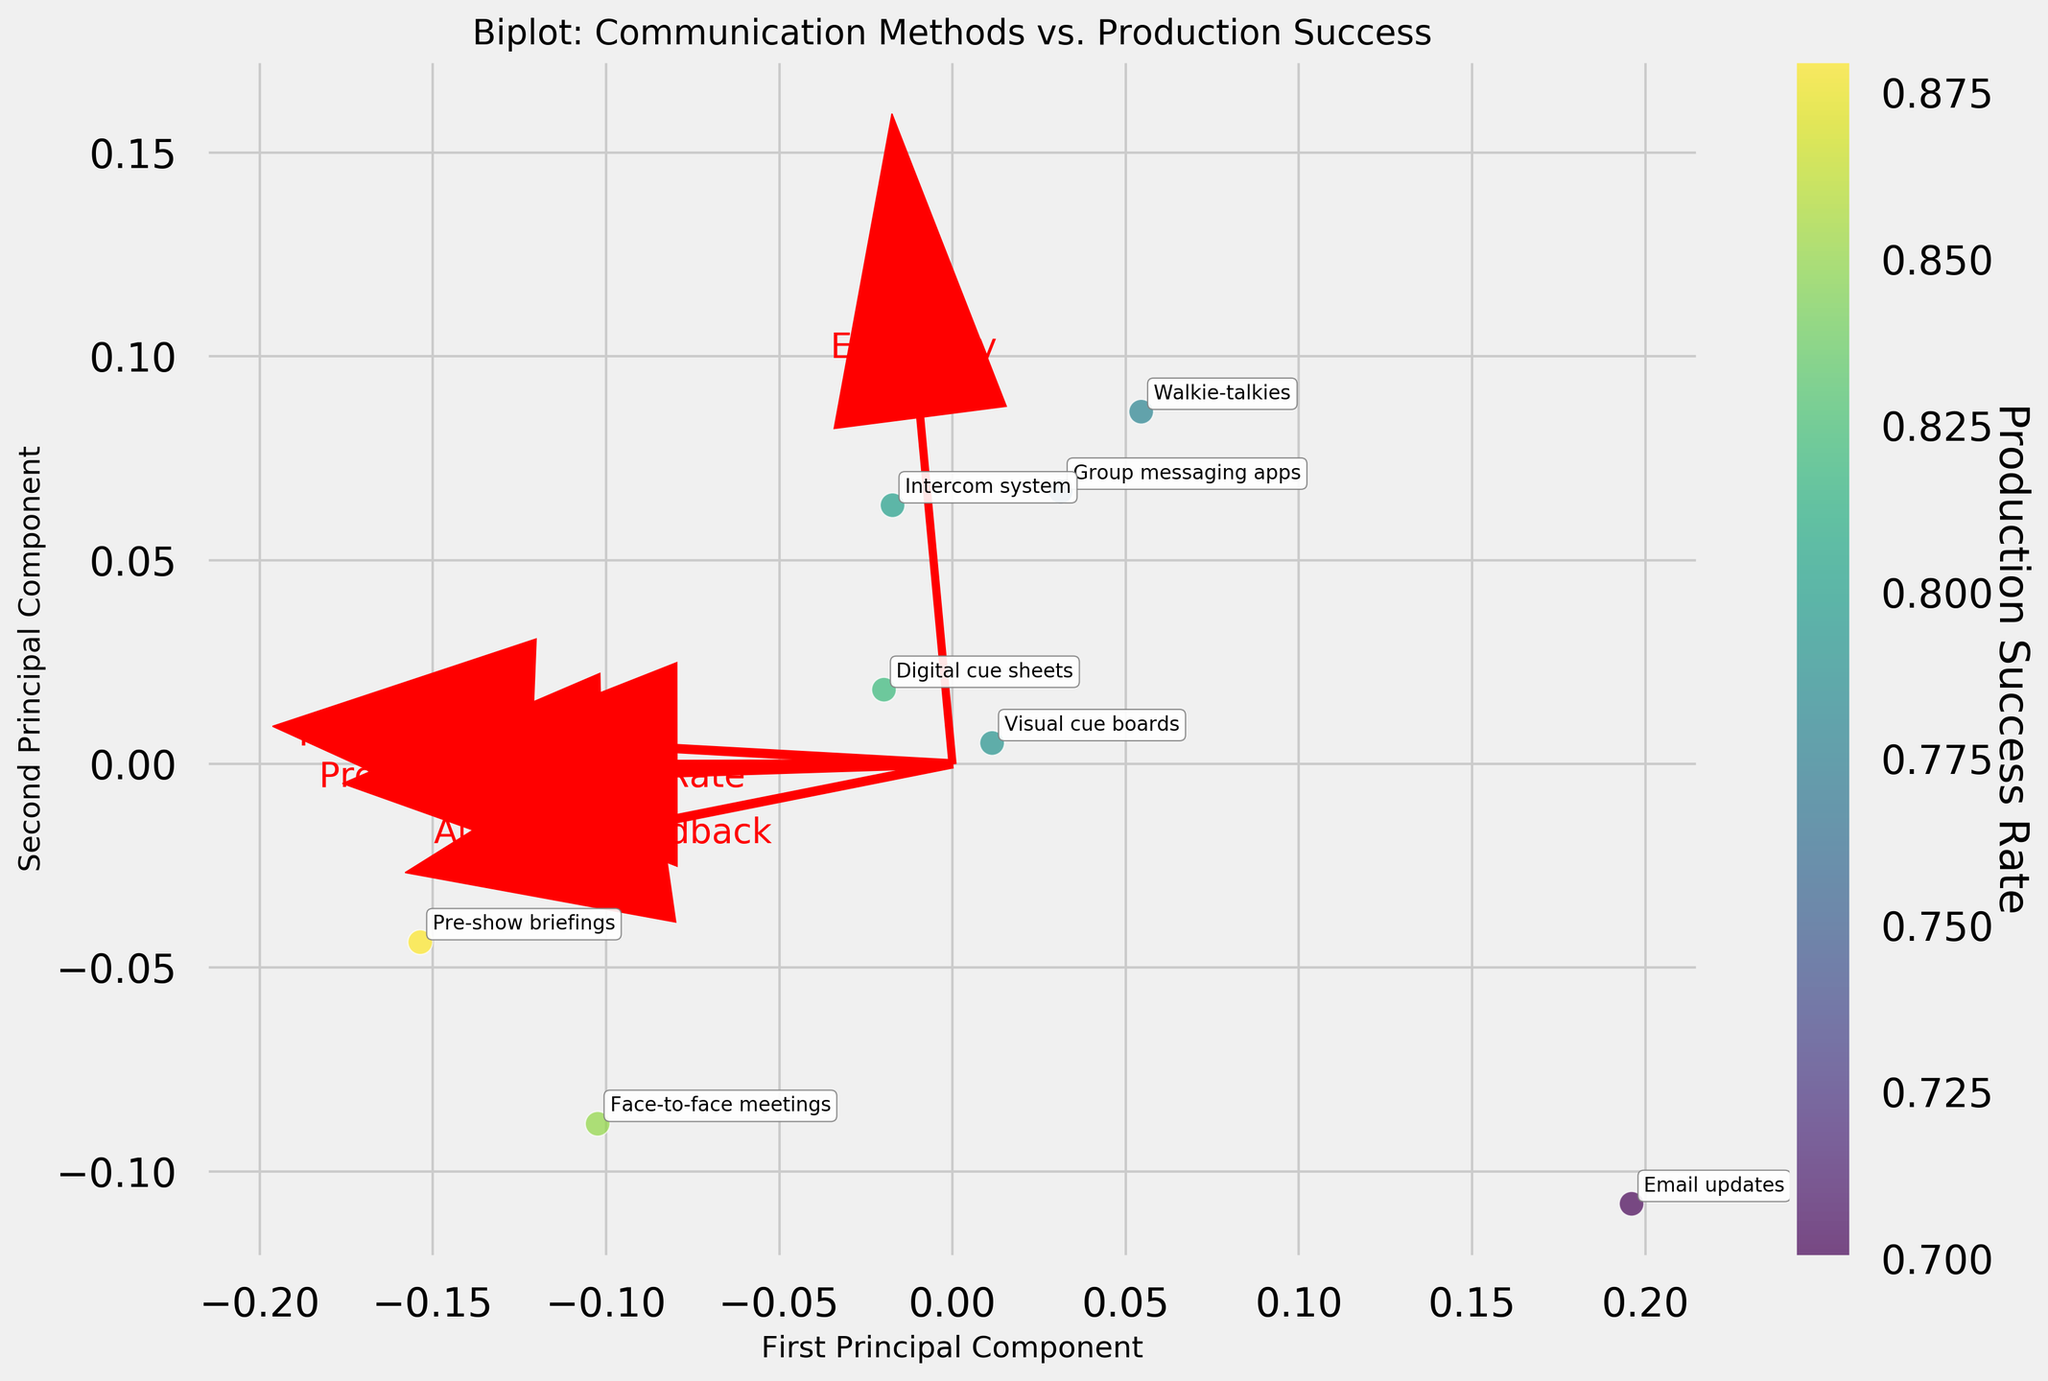What are the communication methods with the highest and lowest production success rates? From the scatter plot, identify the data points and read the corresponding communication methods. According to the plot, 'Pre-show briefings' have the highest production success rate, while 'Email updates' have the lowest.
Answer: 'Pre-show briefings' and 'Email updates' Which communication method is closest to the first principal component's origin? Look for the data point nearest to the origin (0,0) on the scatter plot for the first principal component. 'Group messaging apps' appear closest to the origin.
Answer: 'Group messaging apps' How does 'Walkie-talkies' communication method compare in efficiency and clarity vectors? Observe the feature vectors plotted as arrows for clarity and efficiency. For 'Walkie-talkies', check the relative positioning between efficiency and clarity arrows. 'Walkie-talkies' is closer to the efficiency vector than the clarity vector.
Answer: Closer to efficiency vector Which feature has the strongest influence on the production success rate according to the arrows? Compare the length of feature arrows from the origin. The feature with the longest arrow represents the strongest influence. 'Clarity' has the longest arrow, indicating the strongest influence.
Answer: 'Clarity' Do 'Face-to-face meetings' and 'Intercom system' differ significantly in terms of team satisfaction? Compare the position of 'Face-to-face meetings' and 'Intercom system' relative to the team satisfaction vector. The arrows suggest that 'Face-to-face meetings' are closer to team satisfaction than 'Intercom system'.
Answer: Yes Which features appear to be oppositely correlated based on the plot? Look for feature vectors pointing in nearly opposite directions. 'Clarity' and 'Audience Feedback' arrows appear to be pointing in almost opposite directions.
Answer: 'Clarity' and 'Audience Feedback' Which communication method falls significantly away from 'Pre-show briefings' in the first principal component axis? Identify the position of 'Pre-show briefings' and look for the communication method farthest away along the first principal component axis. 'Email updates' is relatively far away from 'Pre-show briefings'.
Answer: 'Email updates' Are digital cue sheets more aligned with 'efficiency' or 'audience feedback'? Compare the positioning of 'Digital cue sheets' relative to the arrows for 'efficiency' and 'audience feedback'. 'Digital cue sheets' are more aligned with the 'efficiency' vector.
Answer: 'Efficiency' What general direction do most of the communication methods cluster toward in terms of principal components? Notice the general trend or clustering tendency by observing the scatter plot pattern. Most communication methods cluster towards the positively sloped direction of the first principal component.
Answer: Positively sloped direction Which communication method has a notable balance between 'team satisfaction' and 'clarity'? Evaluate the positions of communication methods relative to both the 'team satisfaction' and 'clarity' arrows. 'Face-to-face meetings' align well with both vectors, indicating a balance.
Answer: 'Face-to-face meetings' 